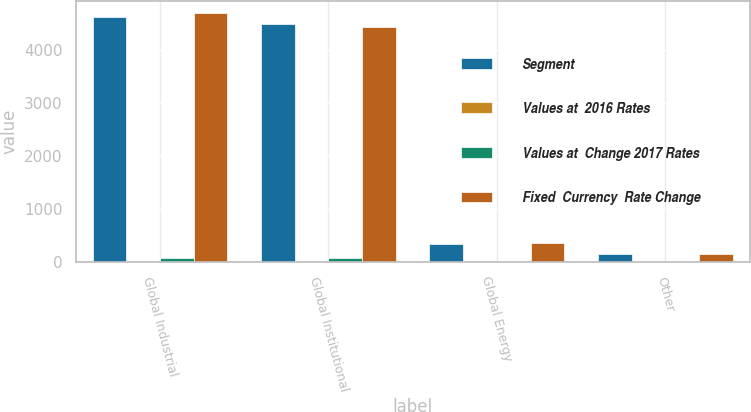<chart> <loc_0><loc_0><loc_500><loc_500><stacked_bar_chart><ecel><fcel>Global Industrial<fcel>Global Institutional<fcel>Global Energy<fcel>Other<nl><fcel>Segment<fcel>4617.1<fcel>4495.6<fcel>337.1<fcel>148.1<nl><fcel>Values at  2016 Rates<fcel>6.9<fcel>7.7<fcel>7.9<fcel>2.5<nl><fcel>Values at  Change 2017 Rates<fcel>63.2<fcel>63.2<fcel>1.7<fcel>0.4<nl><fcel>Fixed  Currency  Rate Change<fcel>4687.2<fcel>4440.1<fcel>346.7<fcel>145.2<nl></chart> 